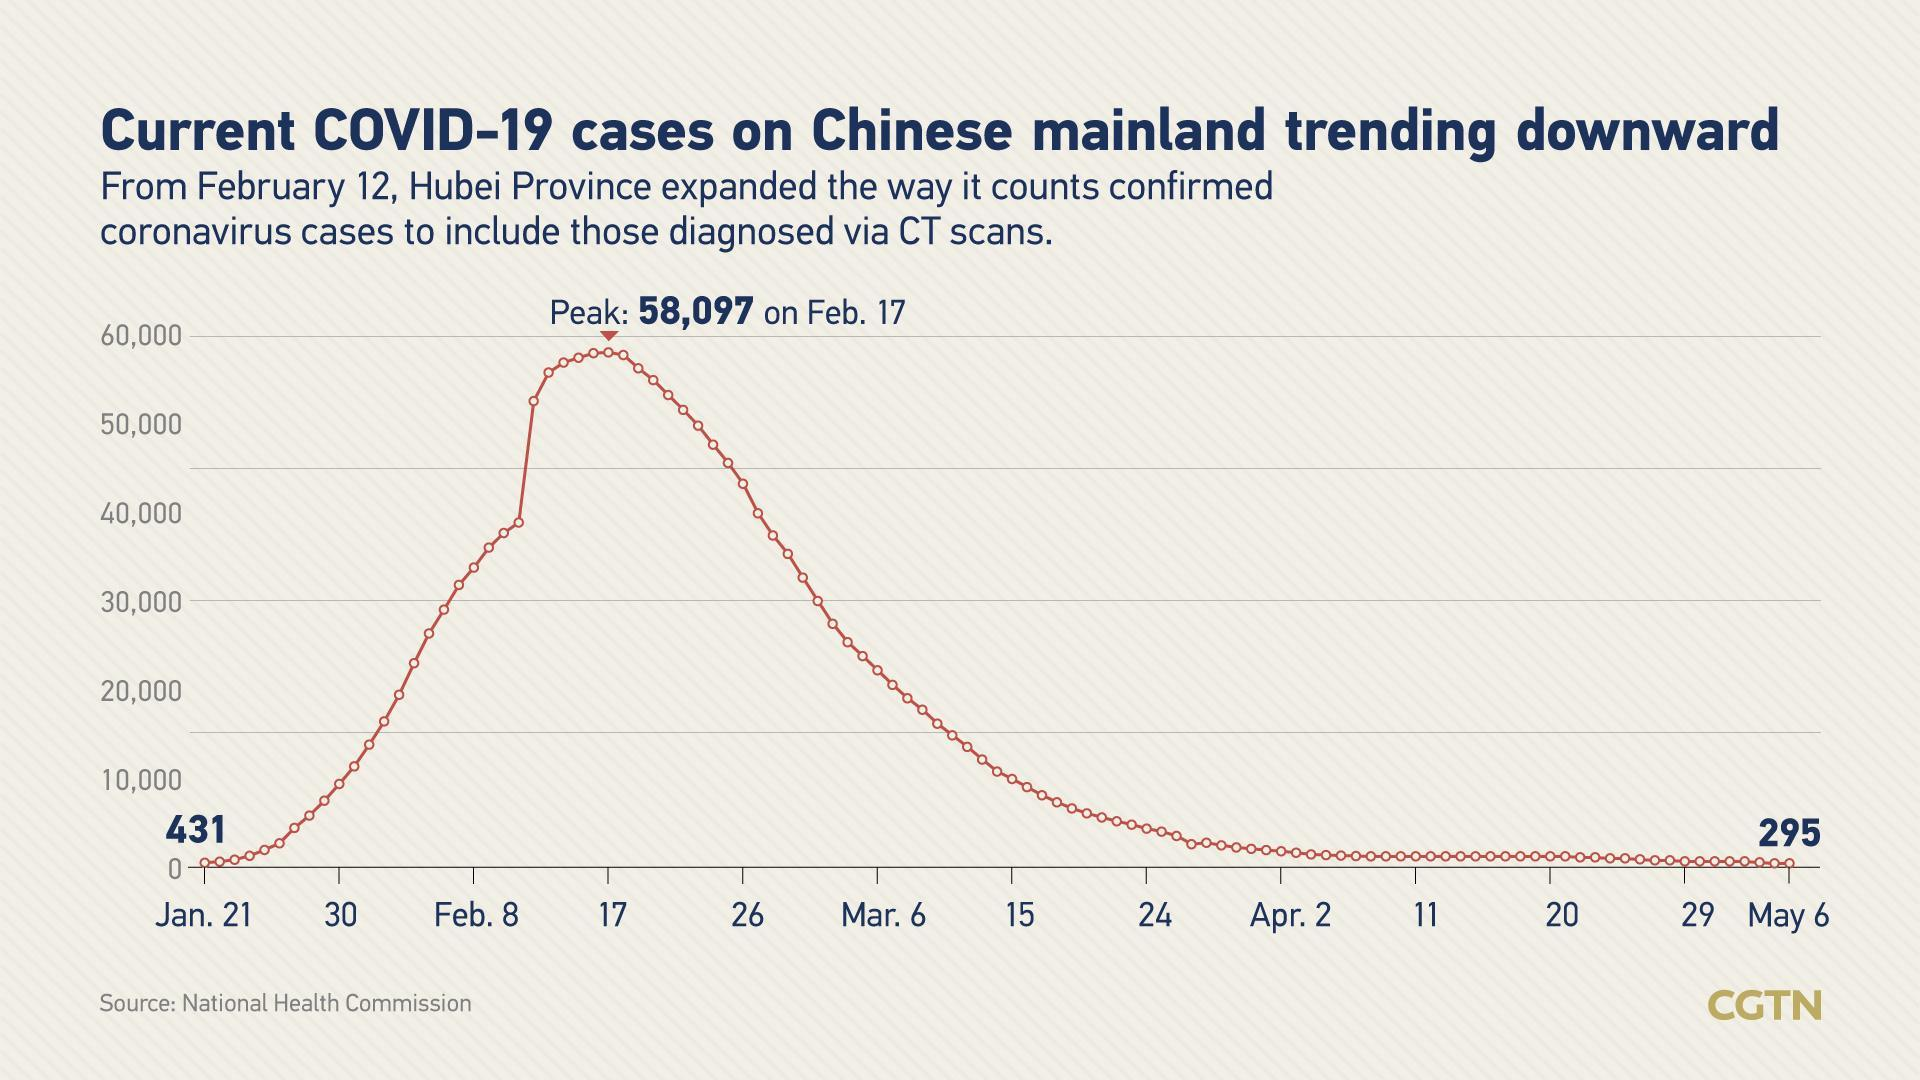How much lesser is the number of coronavirus cases on May 6th, when compared to Jan 21?
Answer the question with a short phrase. 136 Which period showed a vertical surge in the number of corona cases - Feb 17 to Feb 26, Jan21 to Jan 30 or  Feb 8 to Feb 17? Feb 8 to Feb 17 How many months are included in the plot? 5 In which week was the number of corona cases higher - first week of January, first week of February or first week of April? First week of February How much more is the number of corona cases on Feb 17, when compared to Jan 21? 57666 